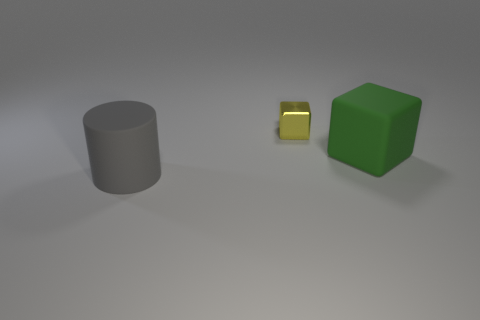Subtract all blocks. How many objects are left? 1 Subtract 2 blocks. How many blocks are left? 0 Subtract all cyan cubes. Subtract all red cylinders. How many cubes are left? 2 Subtract all red spheres. How many yellow cubes are left? 1 Subtract all purple rubber spheres. Subtract all large rubber cylinders. How many objects are left? 2 Add 3 small yellow cubes. How many small yellow cubes are left? 4 Add 2 matte cylinders. How many matte cylinders exist? 3 Add 1 yellow spheres. How many objects exist? 4 Subtract 0 red spheres. How many objects are left? 3 